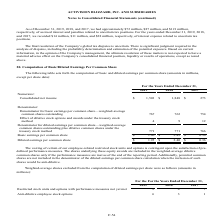According to Activision Blizzard's financial document, What was the consolidated net income in 2018? According to the financial document, $1,848 (in millions). The relevant text states: "Consolidated net income $ 1,503 $ 1,848 $ 273..." Also, What was the consolidated net income in 2019? According to the financial document, $1,503 (in millions). The relevant text states: "Consolidated net income $ 1,503 $ 1,848 $ 273..." Also, What was the Basic earnings per common share in 2017? According to the financial document, $0.36. The relevant text states: "Basic earnings per common share $ 1.96 $ 2.43 $ 0.36..." Also, can you calculate: What was the change in consolidated net income between 2018 and 2019? Based on the calculation: $1,503-$1,848, the result is -345 (in millions). This is based on the information: "Consolidated net income $ 1,503 $ 1,848 $ 273 Consolidated net income $ 1,503 $ 1,848 $ 273..." The key data points involved are: 1,503, 1,848. Also, can you calculate: What was the change in diluted earnings per common share between 2018 and 2019? Based on the calculation: $1.95-$2.40, the result is -0.45. This is based on the information: "Diluted earnings per common share $ 1.95 $ 2.40 $ 0.36 Diluted earnings per common share $ 1.95 $ 2.40 $ 0.36..." The key data points involved are: 1.95, 2.40. Also, can you calculate: What was the percentage change in basic earnings per common share between 2017 and 2018? To answer this question, I need to perform calculations using the financial data. The calculation is: ($2.43-$0.36)/$0.36, which equals 575 (percentage). This is based on the information: "Basic earnings per common share $ 1.96 $ 2.43 $ 0.36 Basic earnings per common share $ 1.96 $ 2.43 $ 0.36..." The key data points involved are: 0.36, 2.43. 